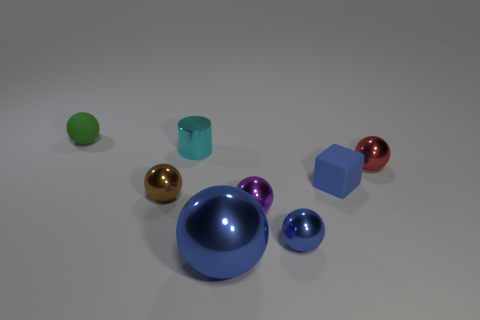Subtract all tiny balls. How many balls are left? 1 Add 1 gray shiny spheres. How many objects exist? 9 Subtract all red balls. How many balls are left? 5 Subtract all balls. How many objects are left? 2 Subtract 1 cylinders. How many cylinders are left? 0 Subtract all yellow spheres. Subtract all green cylinders. How many spheres are left? 6 Subtract all yellow cylinders. How many blue spheres are left? 2 Subtract all red shiny balls. Subtract all big yellow blocks. How many objects are left? 7 Add 4 small red spheres. How many small red spheres are left? 5 Add 5 tiny cyan cylinders. How many tiny cyan cylinders exist? 6 